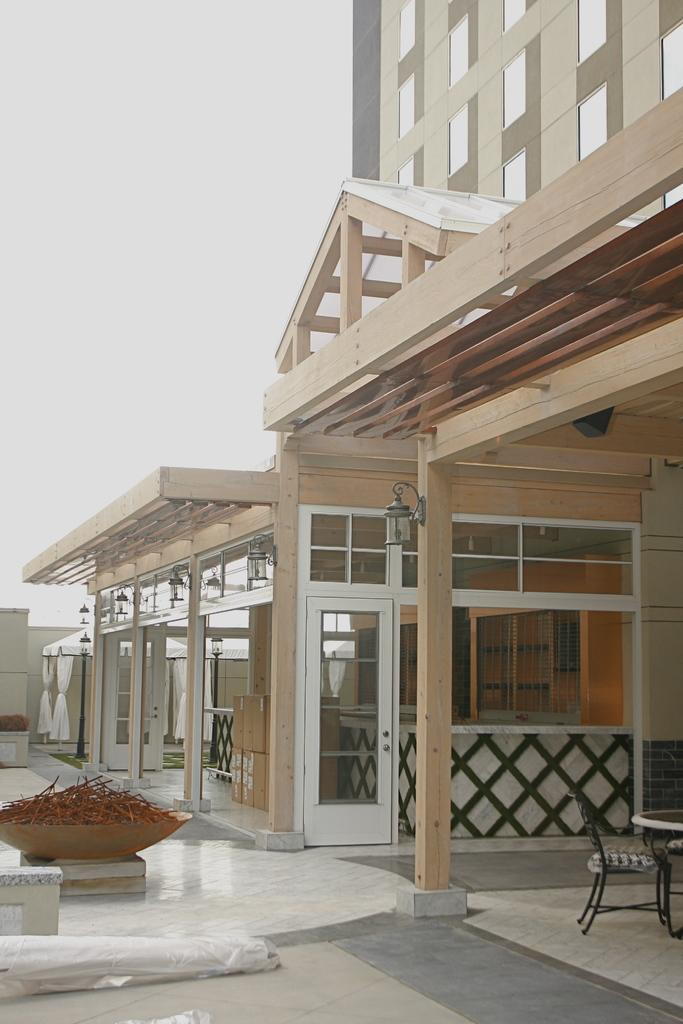What type of structures can be seen in the image? There are buildings in the image. What architectural features are visible on the buildings? There are windows and a door visible in the image. What type of furniture is present in the image? There are chairs and a table in the image. What other objects can be seen in the image? There are other objects in the image, but their specific details are not mentioned in the provided facts. What is the color of the sky in the image? The sky is white in color. Can you see a locket hanging from the door in the image? There is no mention of a locket in the provided facts, and therefore it cannot be confirmed or denied whether one is present in the image. Is there any blood visible on the chairs in the image? There is no mention of blood in the provided facts, and therefore it cannot be confirmed or denied whether it is present in the image. 